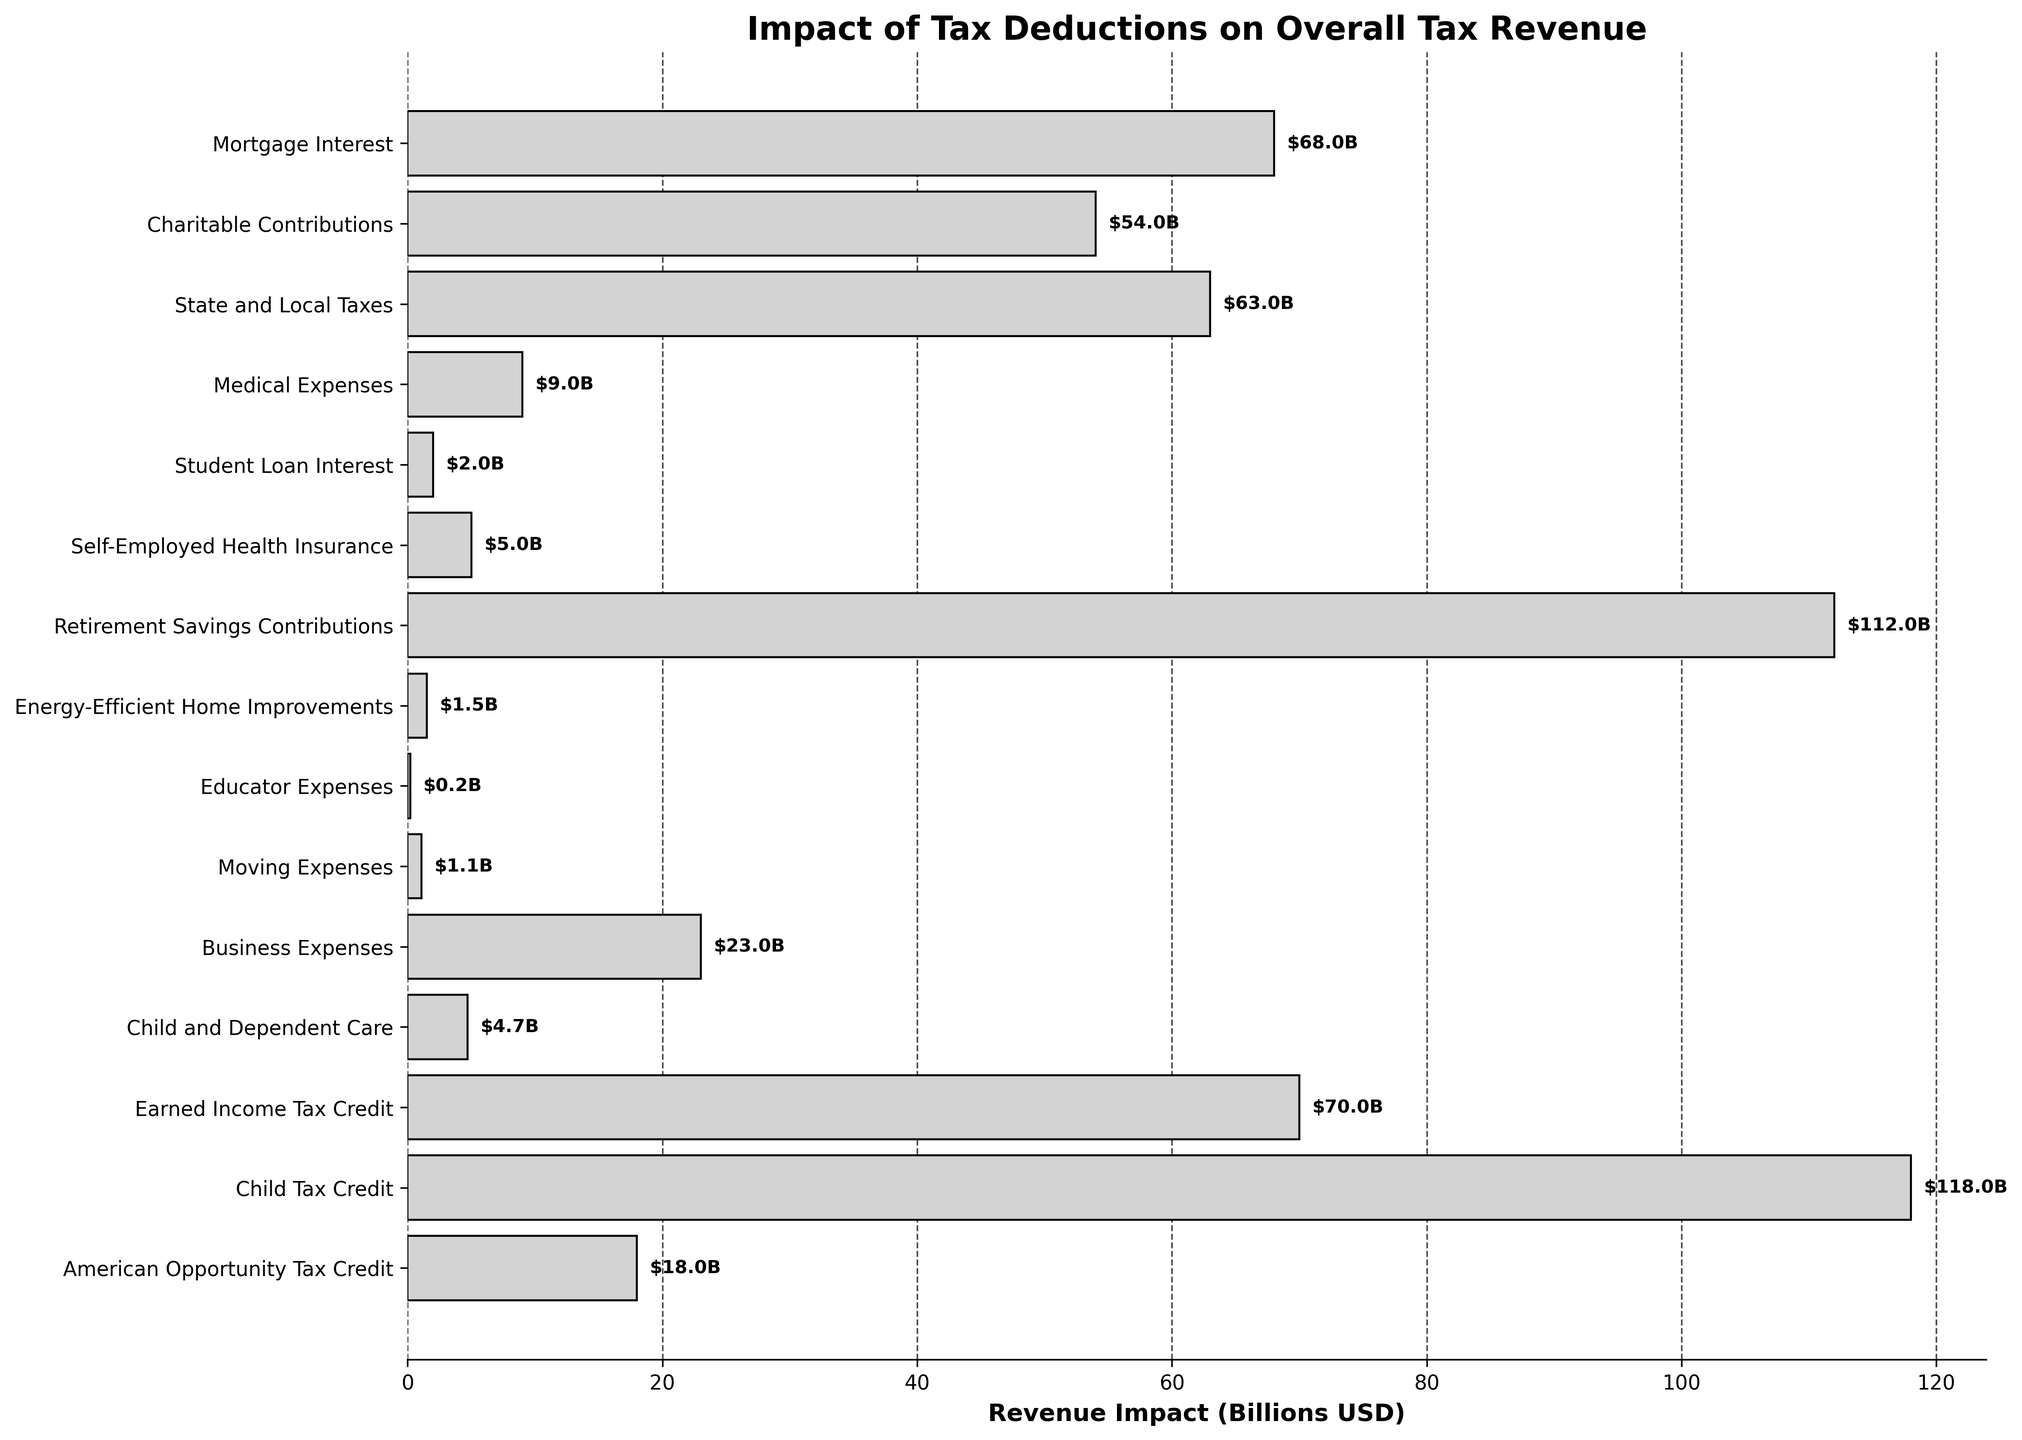Which tax deduction has the largest impact on overall tax revenue? The largest impact can be identified by the length of the bar with the highest value. The longest bar corresponds to the 'Child Tax Credit', which has an impact of $118 billion.
Answer: Child Tax Credit Which tax deduction has the smallest impact on overall tax revenue? The smallest impact can be identified by the shortest bar. The shortest bar corresponds to the 'Educator Expenses', which has an impact of $0.2 billion.
Answer: Educator Expenses Compare the impact of the 'Mortgage Interest' deduction with the 'State and Local Taxes' deduction. Which one has a greater impact? To compare, look at the lengths of the bars for 'Mortgage Interest' and 'State and Local Taxes'. The 'Mortgage Interest' bar shows an impact of $68 billion, while the 'State and Local Taxes' bar shows an impact of $63 billion. Thus, the 'Mortgage Interest' deduction has a greater impact.
Answer: Mortgage Interest What is the total impact on tax revenue from 'Retirement Savings Contributions' and 'Child Tax Credit' deductions? Sum the individual impacts of these deductions: $112 billion (Retirement Savings Contributions) + $118 billion (Child Tax Credit) = $230 billion.
Answer: $230 billion How does the impact of 'Charitable Contributions' compare to 'Business Expenses'? Comparing the two bars, 'Charitable Contributions' has an impact of $54 billion, and 'Business Expenses' has an impact of $23 billion. 'Charitable Contributions' has a larger impact.
Answer: Charitable Contributions Which deduction has an impact closest to $10 billion? By examining the lengths of the bars and the values, the deduction with an impact closest to $10 billion is the 'Medical Expenses' deduction, which has an impact of $9 billion.
Answer: Medical Expenses Calculate the average revenue impact of the 'Medical Expenses', 'Student Loan Interest', and 'Self-Employed Health Insurance' deductions. Summing the individual impacts: $9 billion (Medical Expenses) + $2 billion (Student Loan Interest) + $5 billion (Self-Employed Health Insurance) = $16 billion. Divide by the number of deductions (3): 16 / 3 ≈ $5.3 billion.
Answer: $5.3 billion Which has a greater impact: 'Earned Income Tax Credit' or the combined impact of 'Child and Dependent Care' and 'American Opportunity Tax Credit'? 'Earned Income Tax Credit' has an impact of $70 billion. The combined impact of 'Child and Dependent Care' ($4.7 billion) and 'American Opportunity Tax Credit' ($18 billion) is $4.7 billion + $18 billion = $22.7 billion. The 'Earned Income Tax Credit' alone has a greater impact.
Answer: Earned Income Tax Credit Arrange the top three deductions with the largest impacts in descending order. Identify the three longest bars: 'Child Tax Credit' ($118 billion), 'Retirement Savings Contributions' ($112 billion), 'Earned Income Tax Credit' ($70 billion). Arrange them: 1. Child Tax Credit, 2. Retirement Savings Contributions, 3. Earned Income Tax Credit.
Answer: Child Tax Credit, Retirement Savings Contributions, Earned Income Tax Credit 